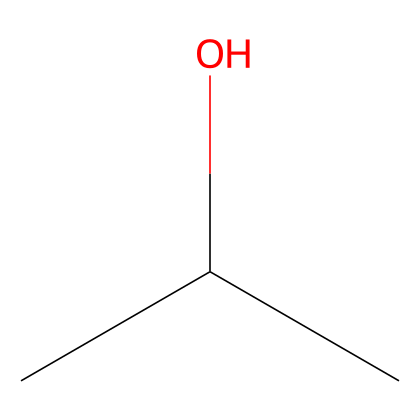What is the common name for this chemical? The SMILES representation corresponds to isopropyl alcohol, which is commonly used as a disinfectant and cleaner.
Answer: isopropyl alcohol How many carbon atoms are present in this structure? The SMILES 'CC(C)O' indicates the presence of three carbon atoms (C) that are connected in the structure.
Answer: 3 What type of functional group is present in isopropyl alcohol? The structure features a hydroxyl (-OH) group attached to a carbon, which is characteristic of alcohols.
Answer: hydroxyl How many hydrogen atoms are in isopropyl alcohol? In the chemical representation 'CC(C)O', each carbon is surrounded by enough hydrogens to satisfy the tetravalency of carbon, totaling 8 hydrogen atoms.
Answer: 8 What physical state is isopropyl alcohol at room temperature? Isopropyl alcohol is a liquid at room temperature, consistent with its use as a cleaner and disinfectant.
Answer: liquid Why is isopropyl alcohol effective for cleaning? Isopropyl alcohol can dissolve oils and fats, acting as a solvent that helps to remove grime and disinfect surfaces.
Answer: solvent How many oxygen atoms are in this chemical? The representation 'CC(C)O' shows that there is one oxygen atom connected to the structure.
Answer: 1 